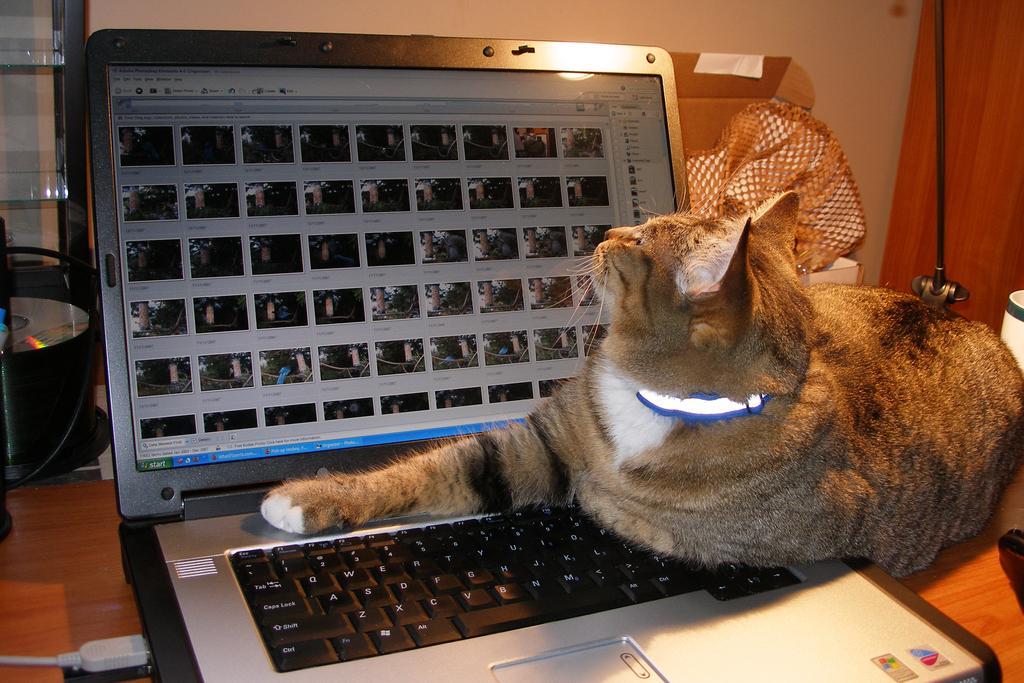Please provide a concise description of this image. In this image I can see a laptop in the front and on it I can see a cat. On the left side of this image I can see a disc and on the right side of this image I can see a black colour stand, a white colour thing and few other stuffs. 